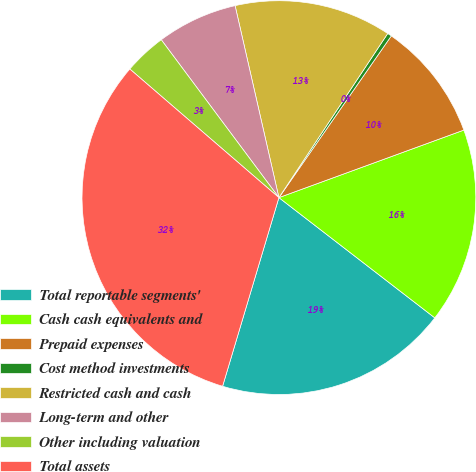<chart> <loc_0><loc_0><loc_500><loc_500><pie_chart><fcel>Total reportable segments'<fcel>Cash cash equivalents and<fcel>Prepaid expenses<fcel>Cost method investments<fcel>Restricted cash and cash<fcel>Long-term and other<fcel>Other including valuation<fcel>Total assets<nl><fcel>19.16%<fcel>16.03%<fcel>9.76%<fcel>0.35%<fcel>12.89%<fcel>6.62%<fcel>3.48%<fcel>31.71%<nl></chart> 